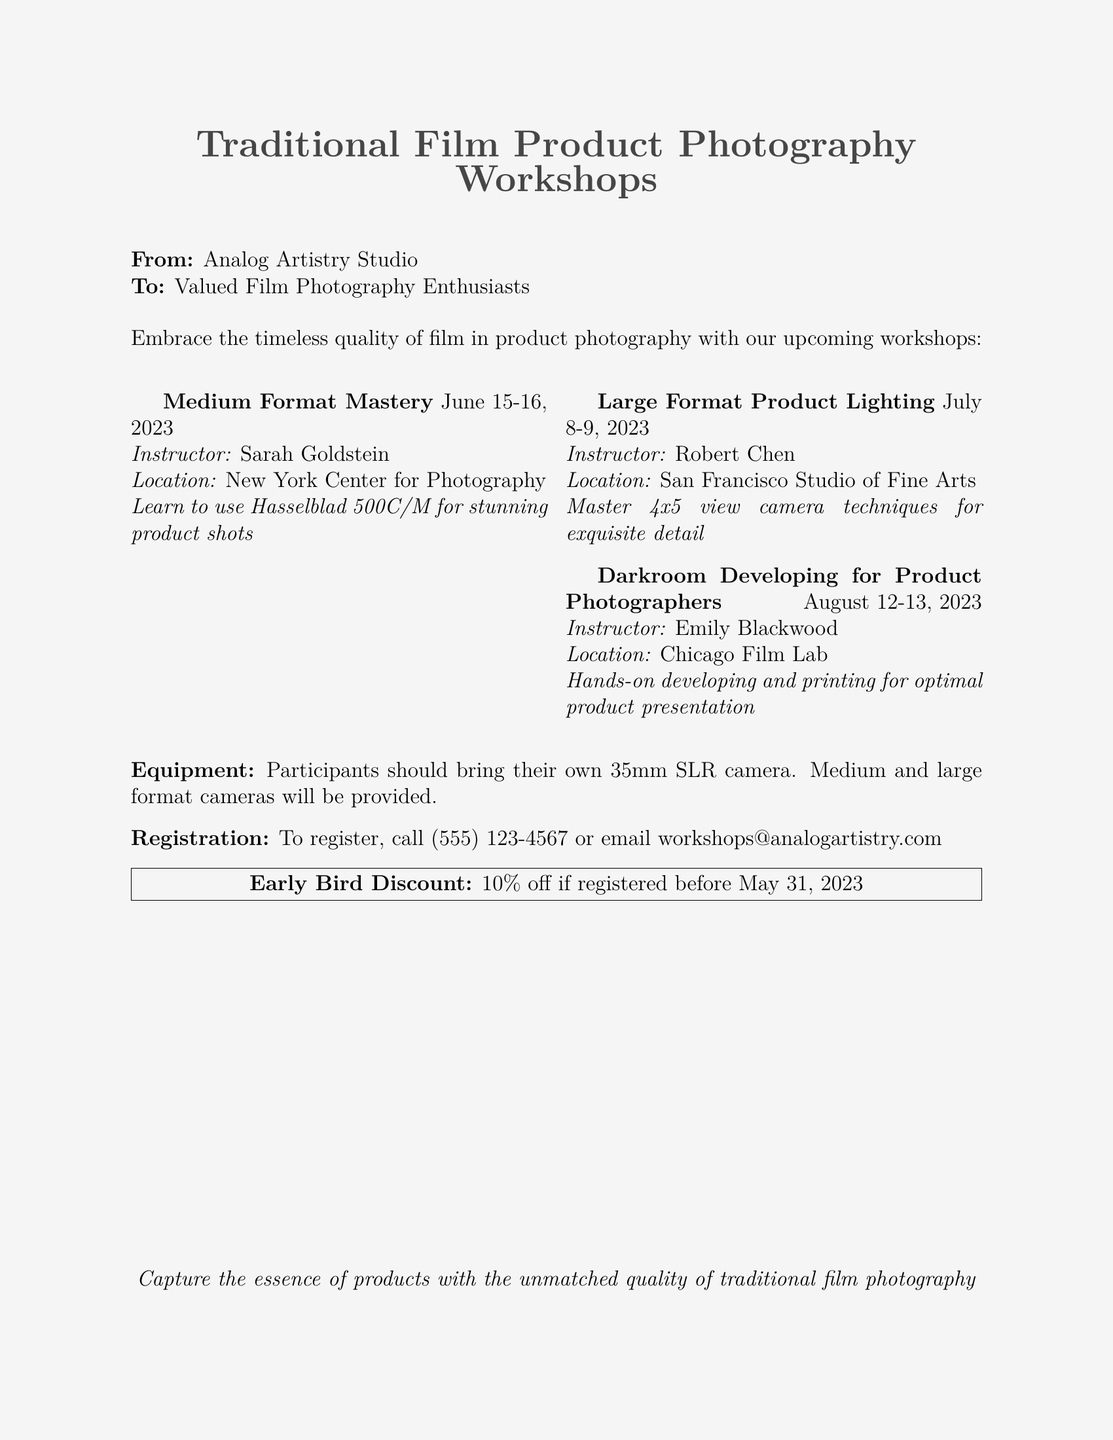What is the name of the first workshop? The first workshop listed is titled "Medium Format Mastery."
Answer: Medium Format Mastery When is the "Large Format Product Lighting" workshop? The document states that this workshop is scheduled for July 8-9, 2023.
Answer: July 8-9, 2023 Who is the instructor for the "Darkroom Developing for Product Photographers" workshop? The instructor for this workshop is Emily Blackwood, as mentioned in the document.
Answer: Emily Blackwood What equipment should participants bring? The document specifies that participants should bring their own 35mm SLR camera.
Answer: 35mm SLR camera Where is the "Medium Format Mastery" workshop located? The location for this workshop is the New York Center for Photography.
Answer: New York Center for Photography What discount is offered for early registration? The document states there is a 10% early bird discount if registered before May 31, 2023.
Answer: 10% How can participants register for the workshops? The document provides contact details for registration, which include a phone number and an email address.
Answer: Call (555) 123-4567 or email workshops@analogartistry.com What is the primary focus of these workshops? The workshops are centered around traditional film techniques for product photography.
Answer: Traditional film techniques for product photography Which type of cameras will be provided during the workshops? The document mentions that medium and large format cameras will be provided to participants.
Answer: Medium and large format cameras 